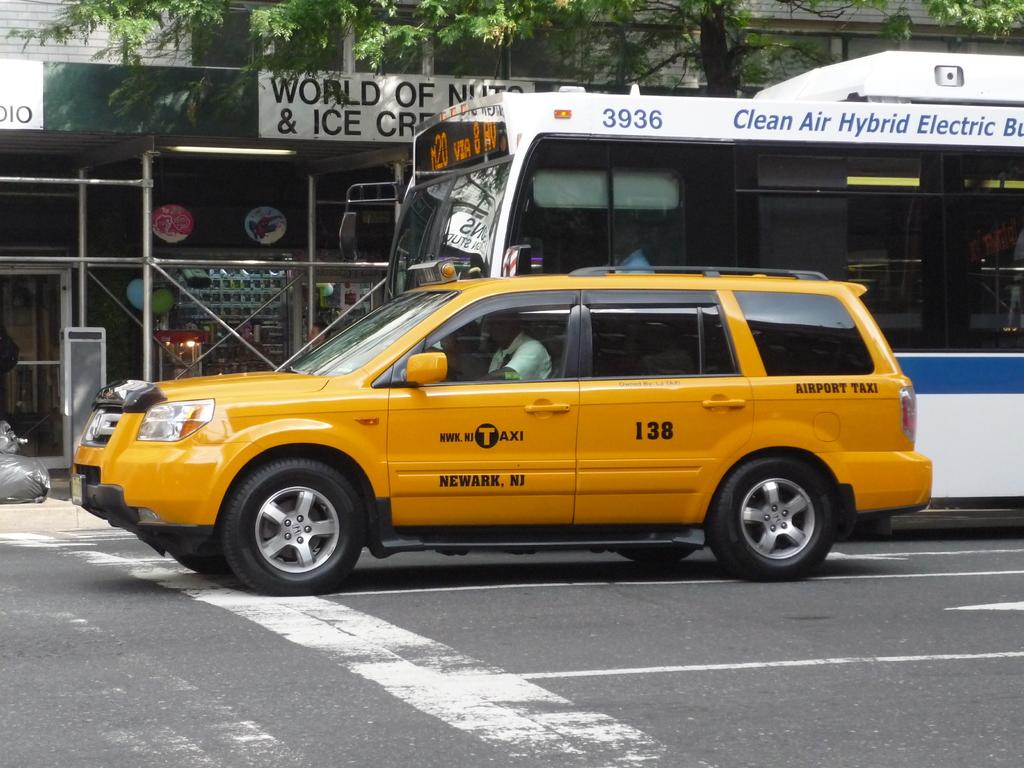<image>
Describe the image concisely. A yellow Neward, New Jersey taxi and public hybrid electric bus approach an intersection. 